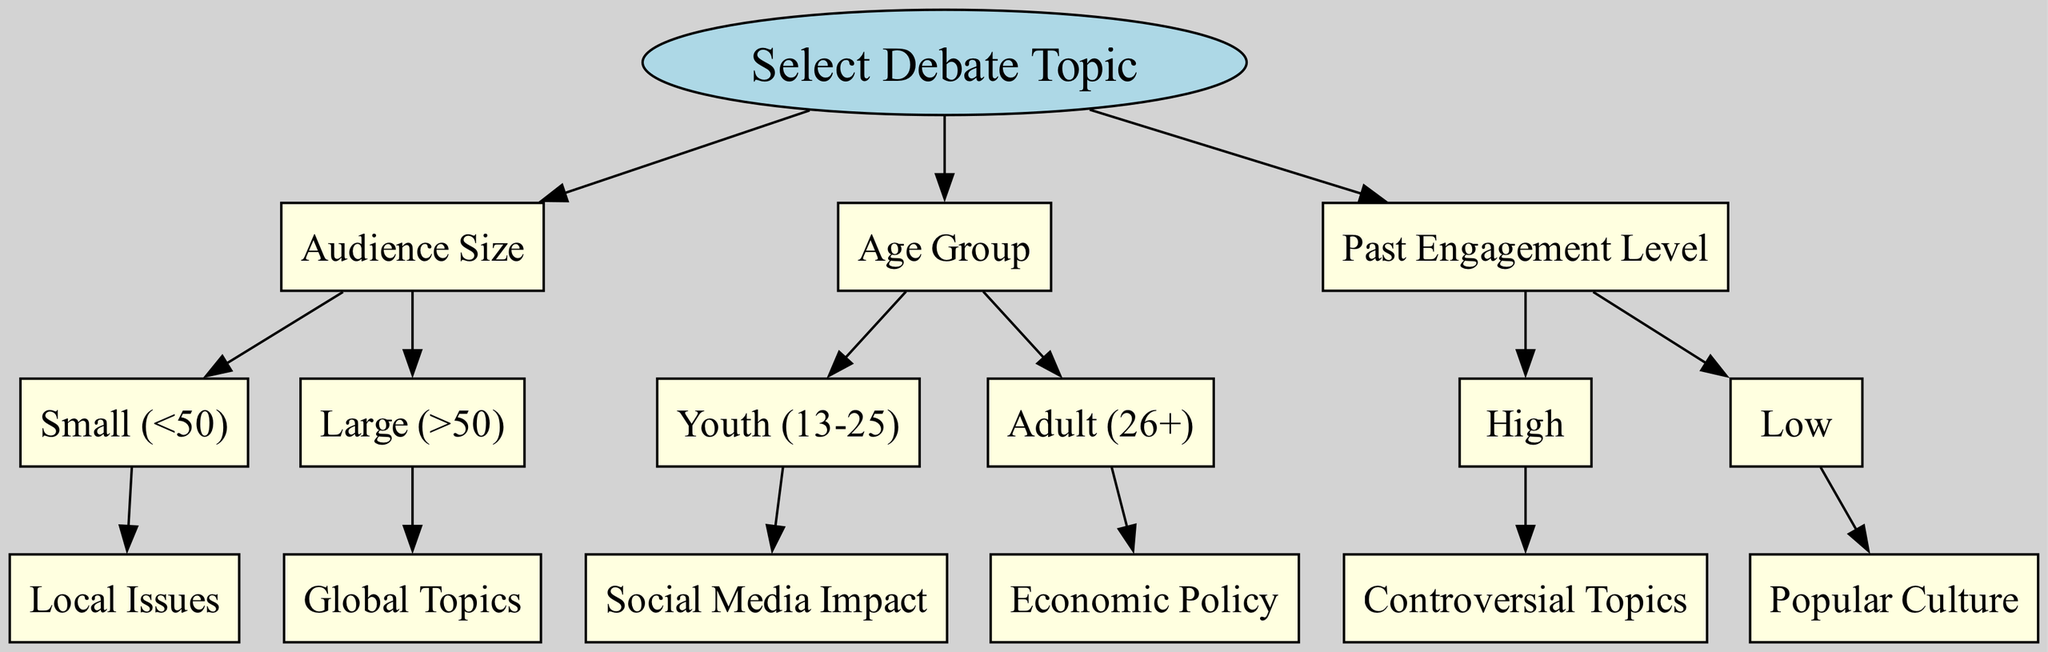What is the root node of the diagram? The root node is labeled "Select Debate Topic". It serves as the starting point for the decision-making process regarding debate topics.
Answer: Select Debate Topic How many main categories of nodes are there under the root node? Under the root node, there are three main categories: "Audience Size", "Age Group", and "Past Engagement Level." Each of these categories has specific criteria to guide topic selection.
Answer: 3 What topic is suggested for a small audience? The diagram indicates that for a small audience, the suggested topic is "Local Issues". This choice is made to further engage a smaller group with relevant discussions.
Answer: Local Issues What is the suggested topic if the audience size is large and the engagement level is high? If the audience size is large and engagement level is high, the topic suggested is "Controversial Topics." This reflects the idea that larger audiences may appreciate stimulating debate.
Answer: Controversial Topics For which age group is the topic "Economic Policy" recommended? The topic "Economic Policy" is recommended for the age group "Adult (26+)." This categorization reflects interests generally more prevalent in older demographics.
Answer: Adult (26+) What type of topics are suggested for youth audiences? For youth audiences, the suggested topics include "Social Media Impact." This is indicative of the relevance of social media in younger generations' discussions and interests.
Answer: Social Media Impact If the past engagement level is low, what topic is suggested? If the past engagement level is low, the suggested topic is "Popular Culture." This aims to engage the audience with lighter, familiar subjects that are generally more accessible.
Answer: Popular Culture Which node leads to the selection of global topics? The node leading to the selection of global topics is "Audience Size" with the condition "Large (>50)." This signifies that larger audiences are approached with broader, more relevant topics.
Answer: Audience Size Are controversial topics associated with low past engagement levels? No, controversial topics are associated with high past engagement levels according to the diagram, making them unsuitable for audiences with low engagement history.
Answer: No 